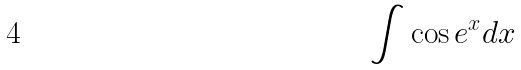<formula> <loc_0><loc_0><loc_500><loc_500>\int \cos e ^ { x } d x</formula> 